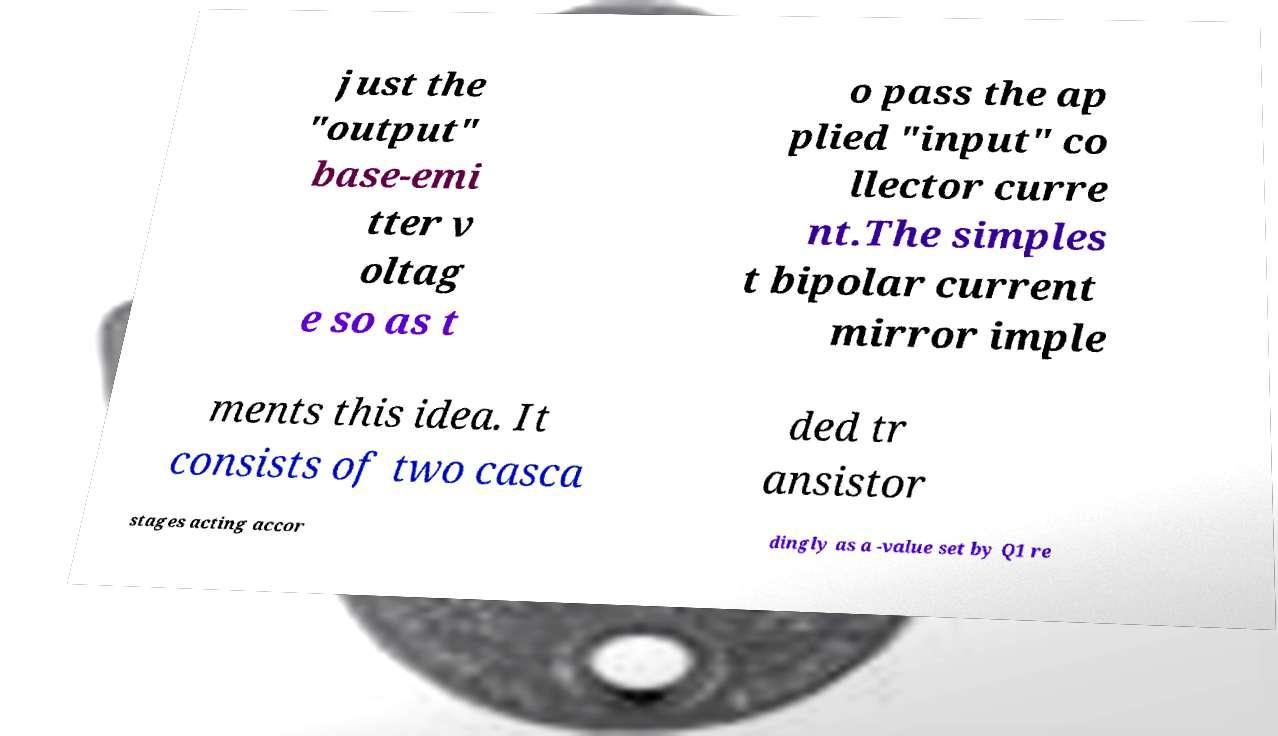There's text embedded in this image that I need extracted. Can you transcribe it verbatim? just the "output" base-emi tter v oltag e so as t o pass the ap plied "input" co llector curre nt.The simples t bipolar current mirror imple ments this idea. It consists of two casca ded tr ansistor stages acting accor dingly as a -value set by Q1 re 